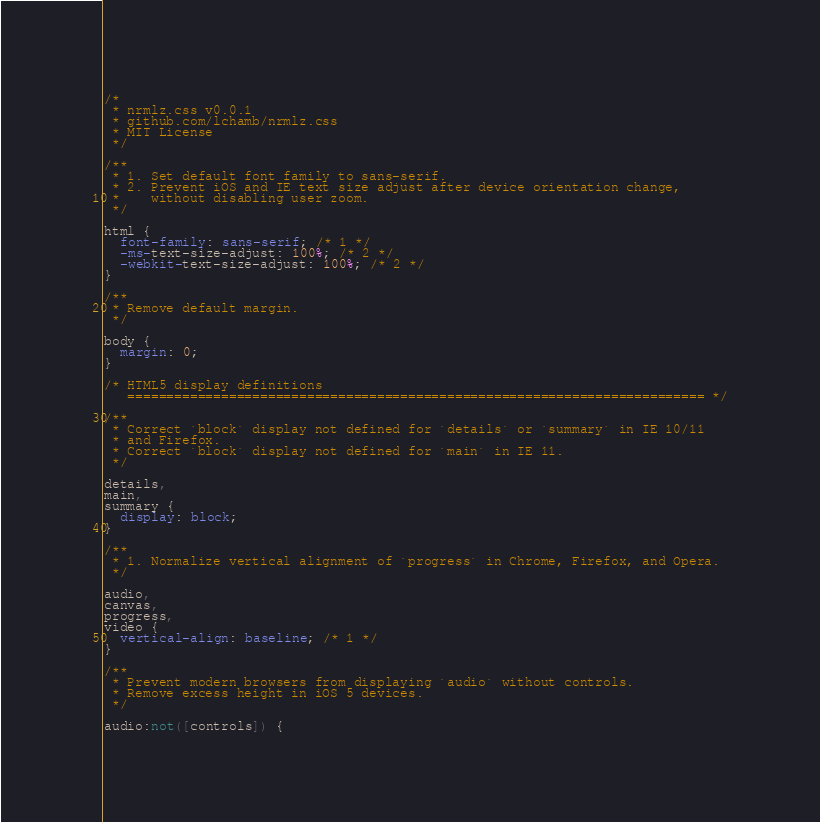<code> <loc_0><loc_0><loc_500><loc_500><_CSS_>/*
 * nrmlz.css v0.0.1
 * github.com/lchamb/nrmlz.css
 * MIT License
 */

/**
 * 1. Set default font family to sans-serif.
 * 2. Prevent iOS and IE text size adjust after device orientation change,
 *    without disabling user zoom.
 */

html {
  font-family: sans-serif; /* 1 */
  -ms-text-size-adjust: 100%; /* 2 */
  -webkit-text-size-adjust: 100%; /* 2 */
}

/**
 * Remove default margin.
 */

body {
  margin: 0;
}

/* HTML5 display definitions
   ========================================================================== */

/**
 * Correct `block` display not defined for `details` or `summary` in IE 10/11
 * and Firefox.
 * Correct `block` display not defined for `main` in IE 11.
 */

details,
main,
summary {
  display: block;
}

/**
 * 1. Normalize vertical alignment of `progress` in Chrome, Firefox, and Opera.
 */

audio,
canvas,
progress,
video {
  vertical-align: baseline; /* 1 */
}

/**
 * Prevent modern browsers from displaying `audio` without controls.
 * Remove excess height in iOS 5 devices.
 */

audio:not([controls]) {</code> 